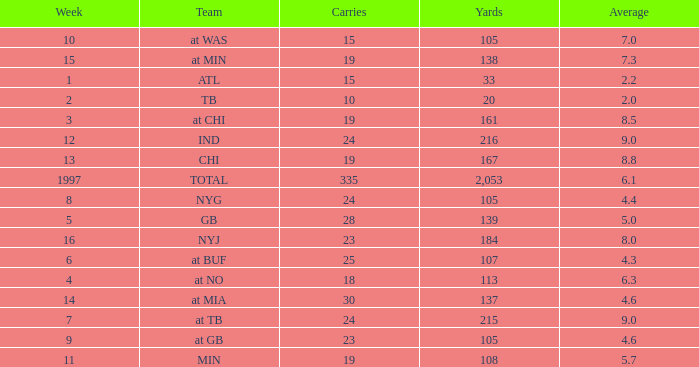Which Team has 19 Carries, and a Week larger than 13? At min. 